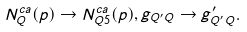<formula> <loc_0><loc_0><loc_500><loc_500>N _ { Q } ^ { c a } ( p ) \rightarrow N _ { Q 5 } ^ { c a } ( p ) , g _ { Q ^ { \prime } Q } \rightarrow g _ { Q ^ { \prime } Q } ^ { \prime } .</formula> 